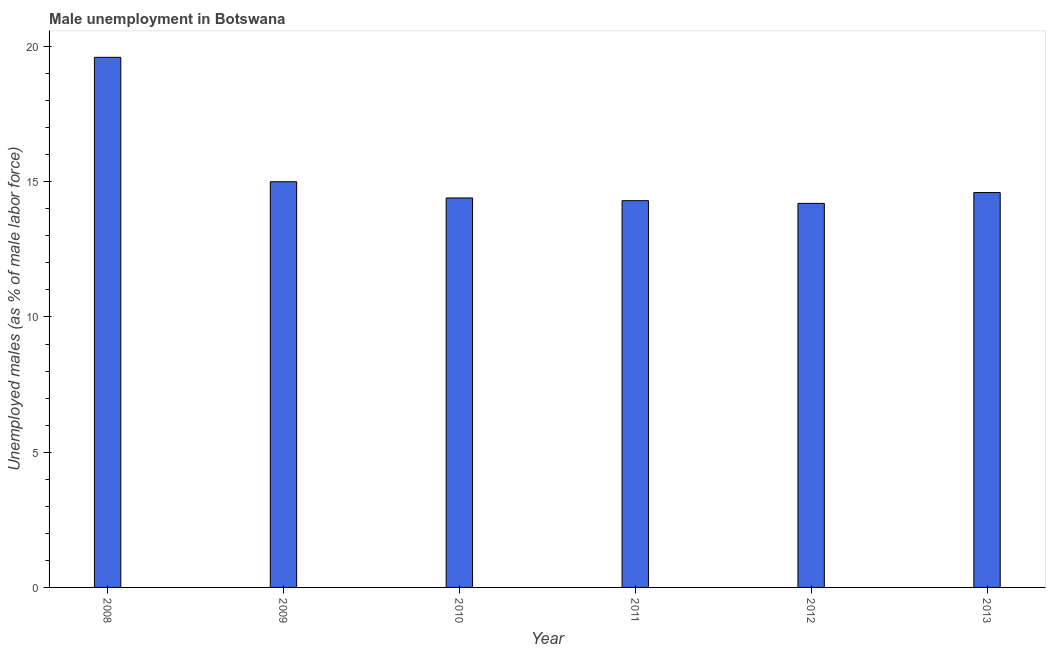What is the title of the graph?
Your response must be concise. Male unemployment in Botswana. What is the label or title of the Y-axis?
Keep it short and to the point. Unemployed males (as % of male labor force). What is the unemployed males population in 2010?
Your answer should be very brief. 14.4. Across all years, what is the maximum unemployed males population?
Offer a very short reply. 19.6. Across all years, what is the minimum unemployed males population?
Your response must be concise. 14.2. What is the sum of the unemployed males population?
Offer a terse response. 92.1. What is the average unemployed males population per year?
Ensure brevity in your answer.  15.35. Do a majority of the years between 2008 and 2009 (inclusive) have unemployed males population greater than 5 %?
Your answer should be very brief. Yes. Is the unemployed males population in 2009 less than that in 2010?
Your answer should be compact. No. Is the difference between the unemployed males population in 2012 and 2013 greater than the difference between any two years?
Make the answer very short. No. Is the sum of the unemployed males population in 2008 and 2009 greater than the maximum unemployed males population across all years?
Your answer should be compact. Yes. In how many years, is the unemployed males population greater than the average unemployed males population taken over all years?
Offer a very short reply. 1. Are all the bars in the graph horizontal?
Offer a terse response. No. How many years are there in the graph?
Make the answer very short. 6. What is the difference between two consecutive major ticks on the Y-axis?
Offer a terse response. 5. Are the values on the major ticks of Y-axis written in scientific E-notation?
Provide a short and direct response. No. What is the Unemployed males (as % of male labor force) in 2008?
Your answer should be compact. 19.6. What is the Unemployed males (as % of male labor force) in 2010?
Your answer should be compact. 14.4. What is the Unemployed males (as % of male labor force) in 2011?
Ensure brevity in your answer.  14.3. What is the Unemployed males (as % of male labor force) in 2012?
Keep it short and to the point. 14.2. What is the Unemployed males (as % of male labor force) of 2013?
Your answer should be compact. 14.6. What is the difference between the Unemployed males (as % of male labor force) in 2008 and 2009?
Keep it short and to the point. 4.6. What is the difference between the Unemployed males (as % of male labor force) in 2008 and 2010?
Your response must be concise. 5.2. What is the difference between the Unemployed males (as % of male labor force) in 2008 and 2011?
Make the answer very short. 5.3. What is the difference between the Unemployed males (as % of male labor force) in 2008 and 2012?
Ensure brevity in your answer.  5.4. What is the difference between the Unemployed males (as % of male labor force) in 2010 and 2012?
Make the answer very short. 0.2. What is the difference between the Unemployed males (as % of male labor force) in 2010 and 2013?
Offer a terse response. -0.2. What is the ratio of the Unemployed males (as % of male labor force) in 2008 to that in 2009?
Your response must be concise. 1.31. What is the ratio of the Unemployed males (as % of male labor force) in 2008 to that in 2010?
Your response must be concise. 1.36. What is the ratio of the Unemployed males (as % of male labor force) in 2008 to that in 2011?
Your answer should be compact. 1.37. What is the ratio of the Unemployed males (as % of male labor force) in 2008 to that in 2012?
Ensure brevity in your answer.  1.38. What is the ratio of the Unemployed males (as % of male labor force) in 2008 to that in 2013?
Provide a succinct answer. 1.34. What is the ratio of the Unemployed males (as % of male labor force) in 2009 to that in 2010?
Give a very brief answer. 1.04. What is the ratio of the Unemployed males (as % of male labor force) in 2009 to that in 2011?
Provide a succinct answer. 1.05. What is the ratio of the Unemployed males (as % of male labor force) in 2009 to that in 2012?
Your answer should be compact. 1.06. What is the ratio of the Unemployed males (as % of male labor force) in 2010 to that in 2012?
Make the answer very short. 1.01. What is the ratio of the Unemployed males (as % of male labor force) in 2010 to that in 2013?
Keep it short and to the point. 0.99. What is the ratio of the Unemployed males (as % of male labor force) in 2012 to that in 2013?
Your response must be concise. 0.97. 